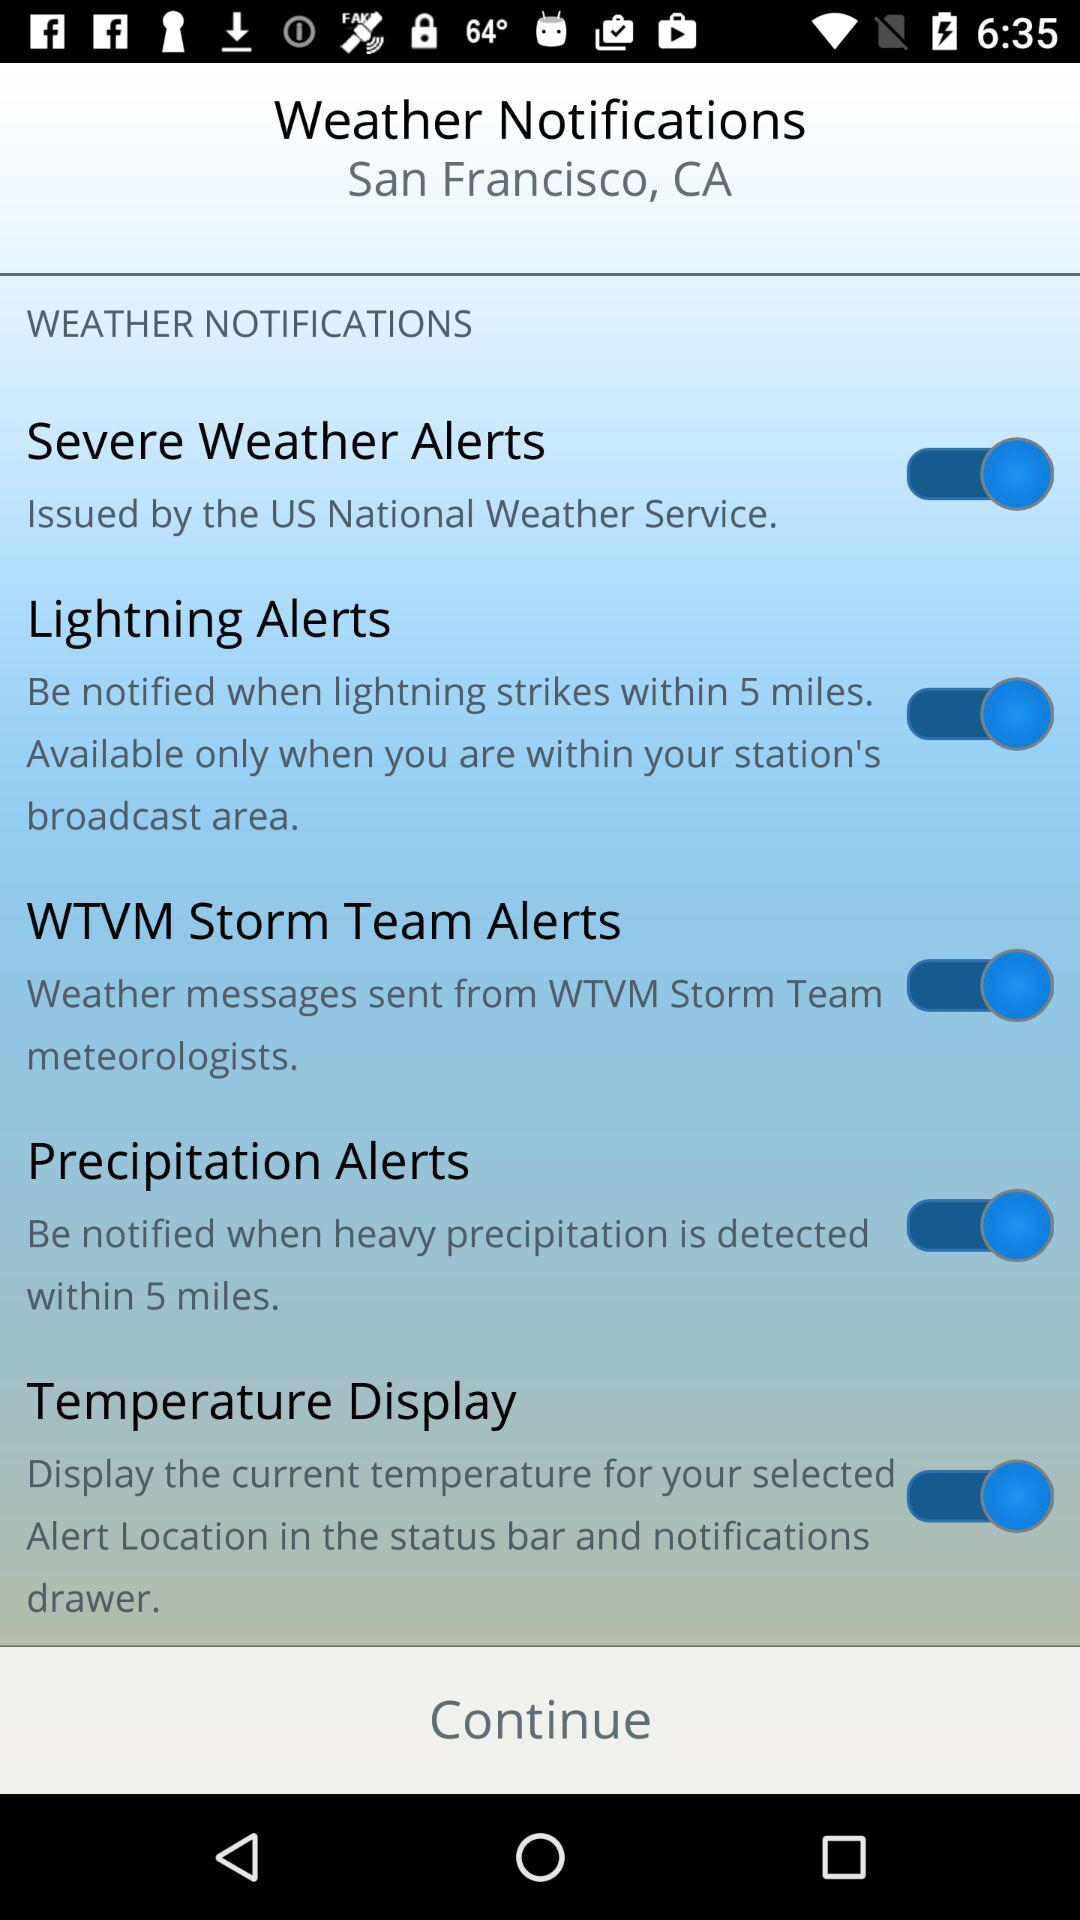What is the status of "Temperature Display"? The status is "on". 